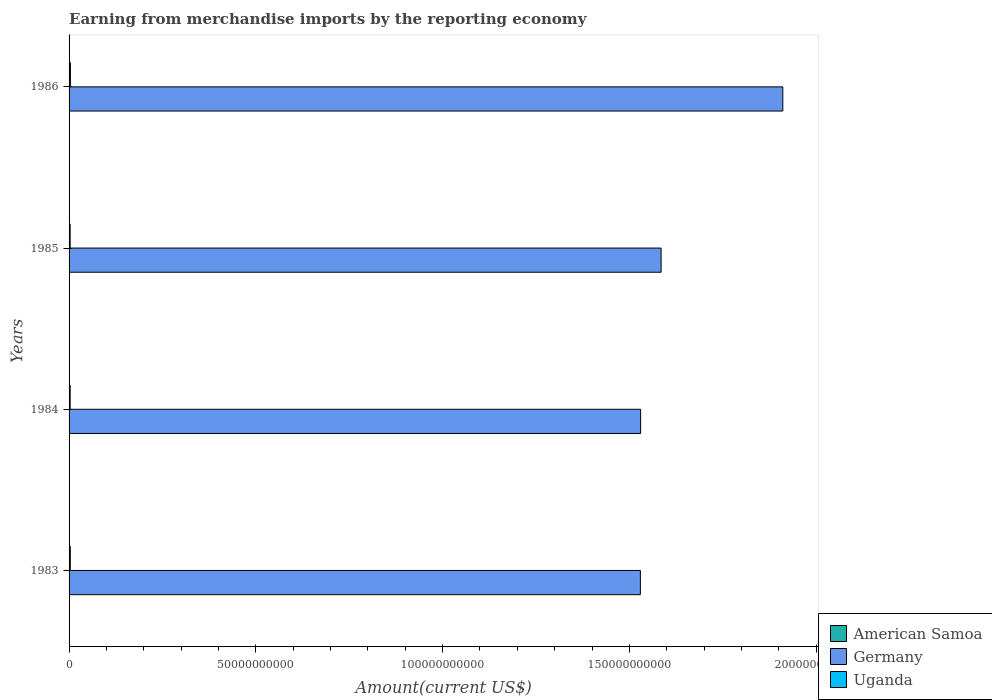How many different coloured bars are there?
Your answer should be compact. 3. Are the number of bars on each tick of the Y-axis equal?
Your answer should be very brief. Yes. How many bars are there on the 3rd tick from the top?
Make the answer very short. 3. What is the label of the 2nd group of bars from the top?
Keep it short and to the point. 1985. What is the amount earned from merchandise imports in Uganda in 1983?
Ensure brevity in your answer.  3.24e+08. Across all years, what is the maximum amount earned from merchandise imports in Uganda?
Offer a terse response. 3.59e+08. Across all years, what is the minimum amount earned from merchandise imports in American Samoa?
Your answer should be compact. 4.81e+07. In which year was the amount earned from merchandise imports in Uganda maximum?
Your answer should be very brief. 1986. In which year was the amount earned from merchandise imports in Uganda minimum?
Offer a very short reply. 1985. What is the total amount earned from merchandise imports in American Samoa in the graph?
Ensure brevity in your answer.  2.25e+08. What is the difference between the amount earned from merchandise imports in Uganda in 1983 and that in 1986?
Your answer should be compact. -3.42e+07. What is the difference between the amount earned from merchandise imports in Germany in 1985 and the amount earned from merchandise imports in Uganda in 1984?
Offer a terse response. 1.58e+11. What is the average amount earned from merchandise imports in Germany per year?
Offer a terse response. 1.64e+11. In the year 1985, what is the difference between the amount earned from merchandise imports in American Samoa and amount earned from merchandise imports in Germany?
Your answer should be very brief. -1.58e+11. In how many years, is the amount earned from merchandise imports in Germany greater than 20000000000 US$?
Keep it short and to the point. 4. What is the ratio of the amount earned from merchandise imports in American Samoa in 1983 to that in 1985?
Ensure brevity in your answer.  0.83. Is the amount earned from merchandise imports in Germany in 1983 less than that in 1986?
Provide a succinct answer. Yes. Is the difference between the amount earned from merchandise imports in American Samoa in 1984 and 1985 greater than the difference between the amount earned from merchandise imports in Germany in 1984 and 1985?
Your response must be concise. Yes. What is the difference between the highest and the second highest amount earned from merchandise imports in Germany?
Your answer should be very brief. 3.26e+1. What is the difference between the highest and the lowest amount earned from merchandise imports in Uganda?
Provide a short and direct response. 7.38e+07. In how many years, is the amount earned from merchandise imports in American Samoa greater than the average amount earned from merchandise imports in American Samoa taken over all years?
Your answer should be compact. 2. Is the sum of the amount earned from merchandise imports in Germany in 1984 and 1986 greater than the maximum amount earned from merchandise imports in Uganda across all years?
Your response must be concise. Yes. What does the 2nd bar from the top in 1986 represents?
Give a very brief answer. Germany. What does the 1st bar from the bottom in 1986 represents?
Provide a succinct answer. American Samoa. Is it the case that in every year, the sum of the amount earned from merchandise imports in Germany and amount earned from merchandise imports in American Samoa is greater than the amount earned from merchandise imports in Uganda?
Keep it short and to the point. Yes. Are all the bars in the graph horizontal?
Your response must be concise. Yes. Does the graph contain grids?
Give a very brief answer. No. How are the legend labels stacked?
Give a very brief answer. Vertical. What is the title of the graph?
Your answer should be very brief. Earning from merchandise imports by the reporting economy. Does "Latin America(developing only)" appear as one of the legend labels in the graph?
Your answer should be compact. No. What is the label or title of the X-axis?
Your answer should be compact. Amount(current US$). What is the Amount(current US$) in American Samoa in 1983?
Keep it short and to the point. 4.81e+07. What is the Amount(current US$) of Germany in 1983?
Keep it short and to the point. 1.53e+11. What is the Amount(current US$) of Uganda in 1983?
Give a very brief answer. 3.24e+08. What is the Amount(current US$) in American Samoa in 1984?
Provide a succinct answer. 5.45e+07. What is the Amount(current US$) in Germany in 1984?
Offer a terse response. 1.53e+11. What is the Amount(current US$) of Uganda in 1984?
Your answer should be compact. 2.90e+08. What is the Amount(current US$) in American Samoa in 1985?
Give a very brief answer. 5.83e+07. What is the Amount(current US$) of Germany in 1985?
Offer a very short reply. 1.58e+11. What is the Amount(current US$) of Uganda in 1985?
Ensure brevity in your answer.  2.85e+08. What is the Amount(current US$) of American Samoa in 1986?
Offer a very short reply. 6.43e+07. What is the Amount(current US$) in Germany in 1986?
Keep it short and to the point. 1.91e+11. What is the Amount(current US$) in Uganda in 1986?
Your answer should be compact. 3.59e+08. Across all years, what is the maximum Amount(current US$) of American Samoa?
Keep it short and to the point. 6.43e+07. Across all years, what is the maximum Amount(current US$) in Germany?
Offer a very short reply. 1.91e+11. Across all years, what is the maximum Amount(current US$) in Uganda?
Ensure brevity in your answer.  3.59e+08. Across all years, what is the minimum Amount(current US$) in American Samoa?
Your response must be concise. 4.81e+07. Across all years, what is the minimum Amount(current US$) of Germany?
Make the answer very short. 1.53e+11. Across all years, what is the minimum Amount(current US$) of Uganda?
Offer a terse response. 2.85e+08. What is the total Amount(current US$) of American Samoa in the graph?
Provide a short and direct response. 2.25e+08. What is the total Amount(current US$) in Germany in the graph?
Provide a succinct answer. 6.55e+11. What is the total Amount(current US$) in Uganda in the graph?
Give a very brief answer. 1.26e+09. What is the difference between the Amount(current US$) in American Samoa in 1983 and that in 1984?
Your response must be concise. -6.35e+06. What is the difference between the Amount(current US$) of Germany in 1983 and that in 1984?
Ensure brevity in your answer.  -6.60e+07. What is the difference between the Amount(current US$) in Uganda in 1983 and that in 1984?
Offer a terse response. 3.46e+07. What is the difference between the Amount(current US$) in American Samoa in 1983 and that in 1985?
Your answer should be very brief. -1.02e+07. What is the difference between the Amount(current US$) of Germany in 1983 and that in 1985?
Offer a very short reply. -5.55e+09. What is the difference between the Amount(current US$) in Uganda in 1983 and that in 1985?
Your answer should be compact. 3.96e+07. What is the difference between the Amount(current US$) of American Samoa in 1983 and that in 1986?
Provide a short and direct response. -1.62e+07. What is the difference between the Amount(current US$) of Germany in 1983 and that in 1986?
Ensure brevity in your answer.  -3.81e+1. What is the difference between the Amount(current US$) of Uganda in 1983 and that in 1986?
Keep it short and to the point. -3.42e+07. What is the difference between the Amount(current US$) of American Samoa in 1984 and that in 1985?
Your answer should be compact. -3.81e+06. What is the difference between the Amount(current US$) of Germany in 1984 and that in 1985?
Make the answer very short. -5.48e+09. What is the difference between the Amount(current US$) of Uganda in 1984 and that in 1985?
Make the answer very short. 4.98e+06. What is the difference between the Amount(current US$) of American Samoa in 1984 and that in 1986?
Make the answer very short. -9.80e+06. What is the difference between the Amount(current US$) of Germany in 1984 and that in 1986?
Give a very brief answer. -3.81e+1. What is the difference between the Amount(current US$) in Uganda in 1984 and that in 1986?
Keep it short and to the point. -6.88e+07. What is the difference between the Amount(current US$) of American Samoa in 1985 and that in 1986?
Make the answer very short. -5.99e+06. What is the difference between the Amount(current US$) of Germany in 1985 and that in 1986?
Offer a terse response. -3.26e+1. What is the difference between the Amount(current US$) of Uganda in 1985 and that in 1986?
Ensure brevity in your answer.  -7.38e+07. What is the difference between the Amount(current US$) of American Samoa in 1983 and the Amount(current US$) of Germany in 1984?
Keep it short and to the point. -1.53e+11. What is the difference between the Amount(current US$) in American Samoa in 1983 and the Amount(current US$) in Uganda in 1984?
Provide a short and direct response. -2.42e+08. What is the difference between the Amount(current US$) of Germany in 1983 and the Amount(current US$) of Uganda in 1984?
Provide a short and direct response. 1.53e+11. What is the difference between the Amount(current US$) of American Samoa in 1983 and the Amount(current US$) of Germany in 1985?
Your answer should be compact. -1.58e+11. What is the difference between the Amount(current US$) in American Samoa in 1983 and the Amount(current US$) in Uganda in 1985?
Offer a terse response. -2.37e+08. What is the difference between the Amount(current US$) of Germany in 1983 and the Amount(current US$) of Uganda in 1985?
Provide a short and direct response. 1.53e+11. What is the difference between the Amount(current US$) in American Samoa in 1983 and the Amount(current US$) in Germany in 1986?
Your answer should be very brief. -1.91e+11. What is the difference between the Amount(current US$) of American Samoa in 1983 and the Amount(current US$) of Uganda in 1986?
Provide a short and direct response. -3.10e+08. What is the difference between the Amount(current US$) of Germany in 1983 and the Amount(current US$) of Uganda in 1986?
Offer a very short reply. 1.53e+11. What is the difference between the Amount(current US$) of American Samoa in 1984 and the Amount(current US$) of Germany in 1985?
Provide a succinct answer. -1.58e+11. What is the difference between the Amount(current US$) in American Samoa in 1984 and the Amount(current US$) in Uganda in 1985?
Make the answer very short. -2.30e+08. What is the difference between the Amount(current US$) of Germany in 1984 and the Amount(current US$) of Uganda in 1985?
Ensure brevity in your answer.  1.53e+11. What is the difference between the Amount(current US$) in American Samoa in 1984 and the Amount(current US$) in Germany in 1986?
Provide a succinct answer. -1.91e+11. What is the difference between the Amount(current US$) of American Samoa in 1984 and the Amount(current US$) of Uganda in 1986?
Make the answer very short. -3.04e+08. What is the difference between the Amount(current US$) in Germany in 1984 and the Amount(current US$) in Uganda in 1986?
Give a very brief answer. 1.53e+11. What is the difference between the Amount(current US$) of American Samoa in 1985 and the Amount(current US$) of Germany in 1986?
Keep it short and to the point. -1.91e+11. What is the difference between the Amount(current US$) in American Samoa in 1985 and the Amount(current US$) in Uganda in 1986?
Your response must be concise. -3.00e+08. What is the difference between the Amount(current US$) of Germany in 1985 and the Amount(current US$) of Uganda in 1986?
Keep it short and to the point. 1.58e+11. What is the average Amount(current US$) in American Samoa per year?
Keep it short and to the point. 5.63e+07. What is the average Amount(current US$) in Germany per year?
Provide a short and direct response. 1.64e+11. What is the average Amount(current US$) of Uganda per year?
Keep it short and to the point. 3.14e+08. In the year 1983, what is the difference between the Amount(current US$) in American Samoa and Amount(current US$) in Germany?
Give a very brief answer. -1.53e+11. In the year 1983, what is the difference between the Amount(current US$) of American Samoa and Amount(current US$) of Uganda?
Your answer should be compact. -2.76e+08. In the year 1983, what is the difference between the Amount(current US$) in Germany and Amount(current US$) in Uganda?
Make the answer very short. 1.53e+11. In the year 1984, what is the difference between the Amount(current US$) of American Samoa and Amount(current US$) of Germany?
Your answer should be compact. -1.53e+11. In the year 1984, what is the difference between the Amount(current US$) in American Samoa and Amount(current US$) in Uganda?
Offer a very short reply. -2.35e+08. In the year 1984, what is the difference between the Amount(current US$) in Germany and Amount(current US$) in Uganda?
Your answer should be compact. 1.53e+11. In the year 1985, what is the difference between the Amount(current US$) of American Samoa and Amount(current US$) of Germany?
Your answer should be compact. -1.58e+11. In the year 1985, what is the difference between the Amount(current US$) of American Samoa and Amount(current US$) of Uganda?
Provide a short and direct response. -2.26e+08. In the year 1985, what is the difference between the Amount(current US$) of Germany and Amount(current US$) of Uganda?
Offer a very short reply. 1.58e+11. In the year 1986, what is the difference between the Amount(current US$) in American Samoa and Amount(current US$) in Germany?
Provide a succinct answer. -1.91e+11. In the year 1986, what is the difference between the Amount(current US$) in American Samoa and Amount(current US$) in Uganda?
Give a very brief answer. -2.94e+08. In the year 1986, what is the difference between the Amount(current US$) in Germany and Amount(current US$) in Uganda?
Offer a terse response. 1.91e+11. What is the ratio of the Amount(current US$) of American Samoa in 1983 to that in 1984?
Ensure brevity in your answer.  0.88. What is the ratio of the Amount(current US$) in Uganda in 1983 to that in 1984?
Your answer should be compact. 1.12. What is the ratio of the Amount(current US$) of American Samoa in 1983 to that in 1985?
Give a very brief answer. 0.83. What is the ratio of the Amount(current US$) of Uganda in 1983 to that in 1985?
Make the answer very short. 1.14. What is the ratio of the Amount(current US$) of American Samoa in 1983 to that in 1986?
Your answer should be very brief. 0.75. What is the ratio of the Amount(current US$) of Germany in 1983 to that in 1986?
Your answer should be very brief. 0.8. What is the ratio of the Amount(current US$) in Uganda in 1983 to that in 1986?
Your answer should be very brief. 0.9. What is the ratio of the Amount(current US$) in American Samoa in 1984 to that in 1985?
Provide a short and direct response. 0.93. What is the ratio of the Amount(current US$) of Germany in 1984 to that in 1985?
Offer a very short reply. 0.97. What is the ratio of the Amount(current US$) of Uganda in 1984 to that in 1985?
Give a very brief answer. 1.02. What is the ratio of the Amount(current US$) of American Samoa in 1984 to that in 1986?
Offer a terse response. 0.85. What is the ratio of the Amount(current US$) in Germany in 1984 to that in 1986?
Your response must be concise. 0.8. What is the ratio of the Amount(current US$) of Uganda in 1984 to that in 1986?
Keep it short and to the point. 0.81. What is the ratio of the Amount(current US$) of American Samoa in 1985 to that in 1986?
Provide a succinct answer. 0.91. What is the ratio of the Amount(current US$) of Germany in 1985 to that in 1986?
Your answer should be compact. 0.83. What is the ratio of the Amount(current US$) in Uganda in 1985 to that in 1986?
Your answer should be very brief. 0.79. What is the difference between the highest and the second highest Amount(current US$) in American Samoa?
Offer a very short reply. 5.99e+06. What is the difference between the highest and the second highest Amount(current US$) in Germany?
Offer a very short reply. 3.26e+1. What is the difference between the highest and the second highest Amount(current US$) of Uganda?
Make the answer very short. 3.42e+07. What is the difference between the highest and the lowest Amount(current US$) of American Samoa?
Offer a very short reply. 1.62e+07. What is the difference between the highest and the lowest Amount(current US$) of Germany?
Offer a terse response. 3.81e+1. What is the difference between the highest and the lowest Amount(current US$) in Uganda?
Your answer should be very brief. 7.38e+07. 